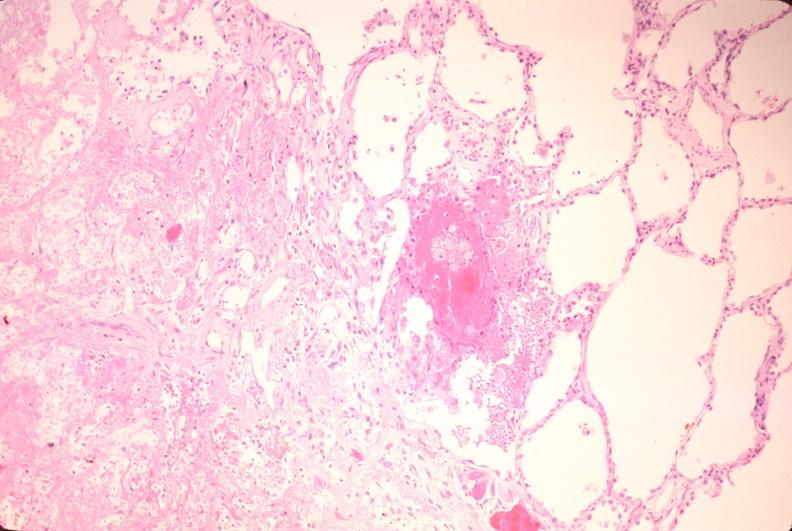where is this?
Answer the question using a single word or phrase. Lung 